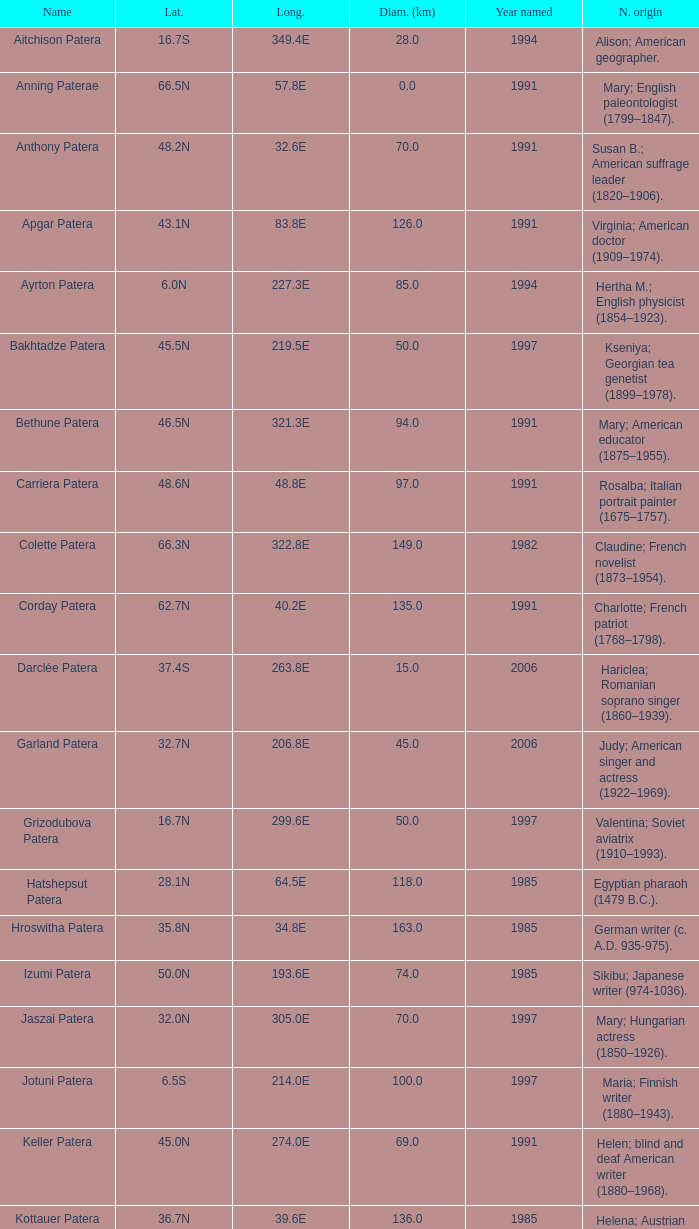What is the longitude of the feature named Razia Patera?  197.8E. 